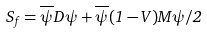<formula> <loc_0><loc_0><loc_500><loc_500>S _ { f } = \overline { \psi } D \psi + \overline { \psi } ( 1 - V ) M \psi / 2</formula> 